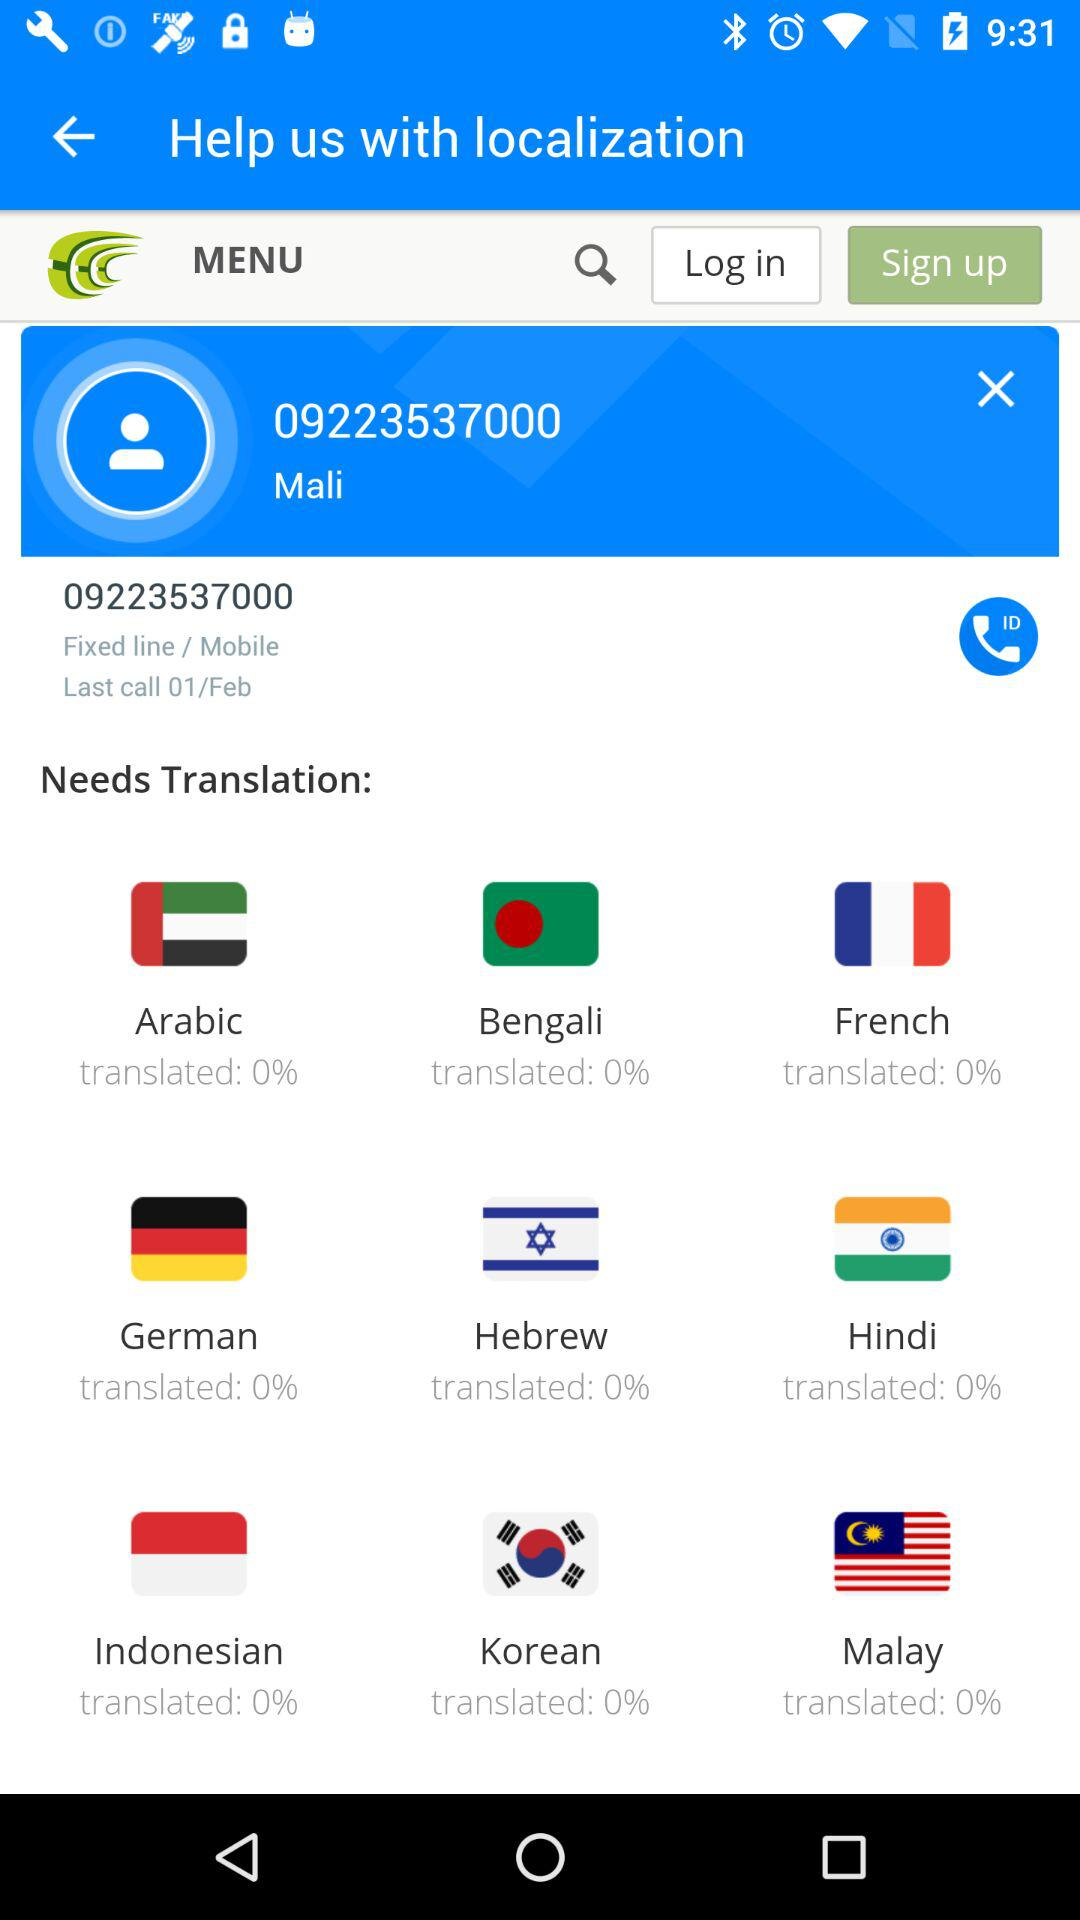On what date was the last call from Mali? The last call from Mali is on February 1. 